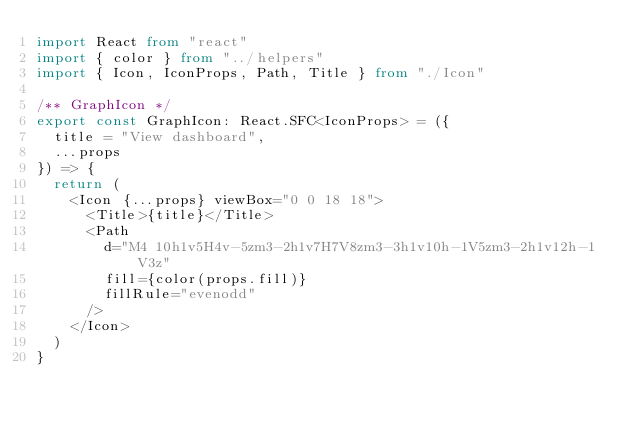Convert code to text. <code><loc_0><loc_0><loc_500><loc_500><_TypeScript_>import React from "react"
import { color } from "../helpers"
import { Icon, IconProps, Path, Title } from "./Icon"

/** GraphIcon */
export const GraphIcon: React.SFC<IconProps> = ({
  title = "View dashboard",
  ...props
}) => {
  return (
    <Icon {...props} viewBox="0 0 18 18">
      <Title>{title}</Title>
      <Path
        d="M4 10h1v5H4v-5zm3-2h1v7H7V8zm3-3h1v10h-1V5zm3-2h1v12h-1V3z"
        fill={color(props.fill)}
        fillRule="evenodd"
      />
    </Icon>
  )
}
</code> 